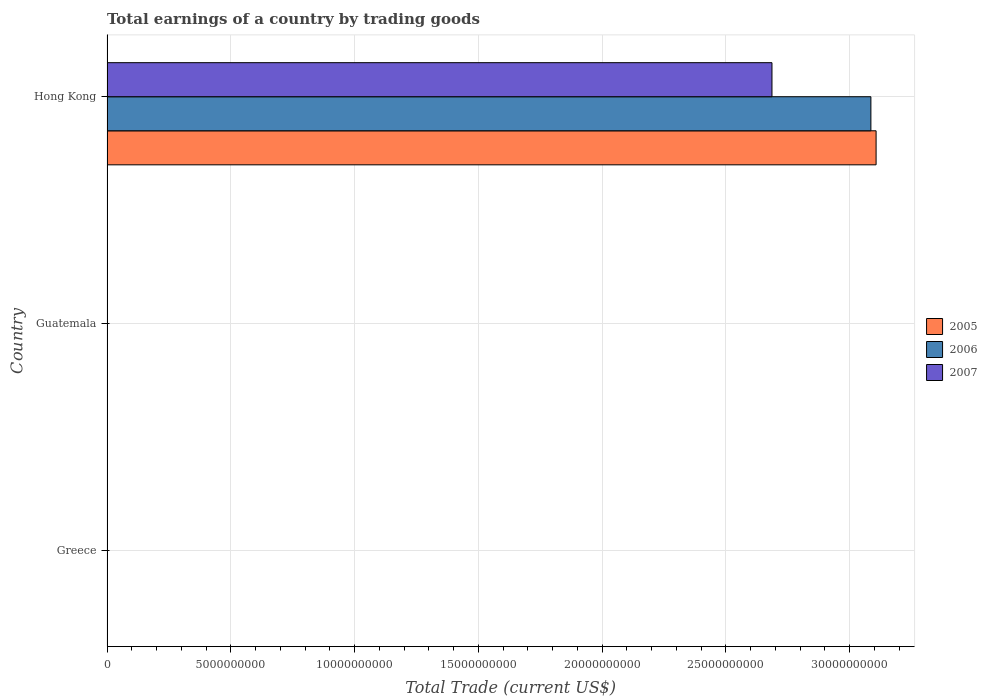How many bars are there on the 2nd tick from the bottom?
Ensure brevity in your answer.  0. What is the label of the 2nd group of bars from the top?
Your answer should be compact. Guatemala. What is the total earnings in 2005 in Greece?
Offer a terse response. 0. Across all countries, what is the maximum total earnings in 2007?
Provide a succinct answer. 2.69e+1. In which country was the total earnings in 2006 maximum?
Ensure brevity in your answer.  Hong Kong. What is the total total earnings in 2007 in the graph?
Give a very brief answer. 2.69e+1. What is the difference between the total earnings in 2007 in Guatemala and the total earnings in 2005 in Hong Kong?
Keep it short and to the point. -3.11e+1. What is the average total earnings in 2006 per country?
Your answer should be very brief. 1.03e+1. What is the difference between the total earnings in 2007 and total earnings in 2006 in Hong Kong?
Offer a terse response. -4.00e+09. In how many countries, is the total earnings in 2005 greater than 28000000000 US$?
Your answer should be very brief. 1. What is the difference between the highest and the lowest total earnings in 2005?
Ensure brevity in your answer.  3.11e+1. How many bars are there?
Offer a very short reply. 3. How many countries are there in the graph?
Offer a terse response. 3. What is the difference between two consecutive major ticks on the X-axis?
Make the answer very short. 5.00e+09. What is the title of the graph?
Your answer should be compact. Total earnings of a country by trading goods. Does "1985" appear as one of the legend labels in the graph?
Provide a succinct answer. No. What is the label or title of the X-axis?
Your response must be concise. Total Trade (current US$). What is the label or title of the Y-axis?
Your answer should be compact. Country. What is the Total Trade (current US$) of 2007 in Greece?
Offer a terse response. 0. What is the Total Trade (current US$) of 2005 in Guatemala?
Provide a short and direct response. 0. What is the Total Trade (current US$) of 2005 in Hong Kong?
Your answer should be very brief. 3.11e+1. What is the Total Trade (current US$) of 2006 in Hong Kong?
Provide a short and direct response. 3.09e+1. What is the Total Trade (current US$) of 2007 in Hong Kong?
Give a very brief answer. 2.69e+1. Across all countries, what is the maximum Total Trade (current US$) of 2005?
Give a very brief answer. 3.11e+1. Across all countries, what is the maximum Total Trade (current US$) of 2006?
Keep it short and to the point. 3.09e+1. Across all countries, what is the maximum Total Trade (current US$) in 2007?
Offer a terse response. 2.69e+1. Across all countries, what is the minimum Total Trade (current US$) of 2006?
Ensure brevity in your answer.  0. What is the total Total Trade (current US$) in 2005 in the graph?
Provide a short and direct response. 3.11e+1. What is the total Total Trade (current US$) of 2006 in the graph?
Offer a terse response. 3.09e+1. What is the total Total Trade (current US$) of 2007 in the graph?
Ensure brevity in your answer.  2.69e+1. What is the average Total Trade (current US$) in 2005 per country?
Offer a terse response. 1.04e+1. What is the average Total Trade (current US$) in 2006 per country?
Keep it short and to the point. 1.03e+1. What is the average Total Trade (current US$) in 2007 per country?
Your answer should be very brief. 8.95e+09. What is the difference between the Total Trade (current US$) in 2005 and Total Trade (current US$) in 2006 in Hong Kong?
Offer a very short reply. 2.11e+08. What is the difference between the Total Trade (current US$) in 2005 and Total Trade (current US$) in 2007 in Hong Kong?
Give a very brief answer. 4.21e+09. What is the difference between the Total Trade (current US$) of 2006 and Total Trade (current US$) of 2007 in Hong Kong?
Provide a succinct answer. 4.00e+09. What is the difference between the highest and the lowest Total Trade (current US$) of 2005?
Provide a short and direct response. 3.11e+1. What is the difference between the highest and the lowest Total Trade (current US$) of 2006?
Give a very brief answer. 3.09e+1. What is the difference between the highest and the lowest Total Trade (current US$) of 2007?
Make the answer very short. 2.69e+1. 